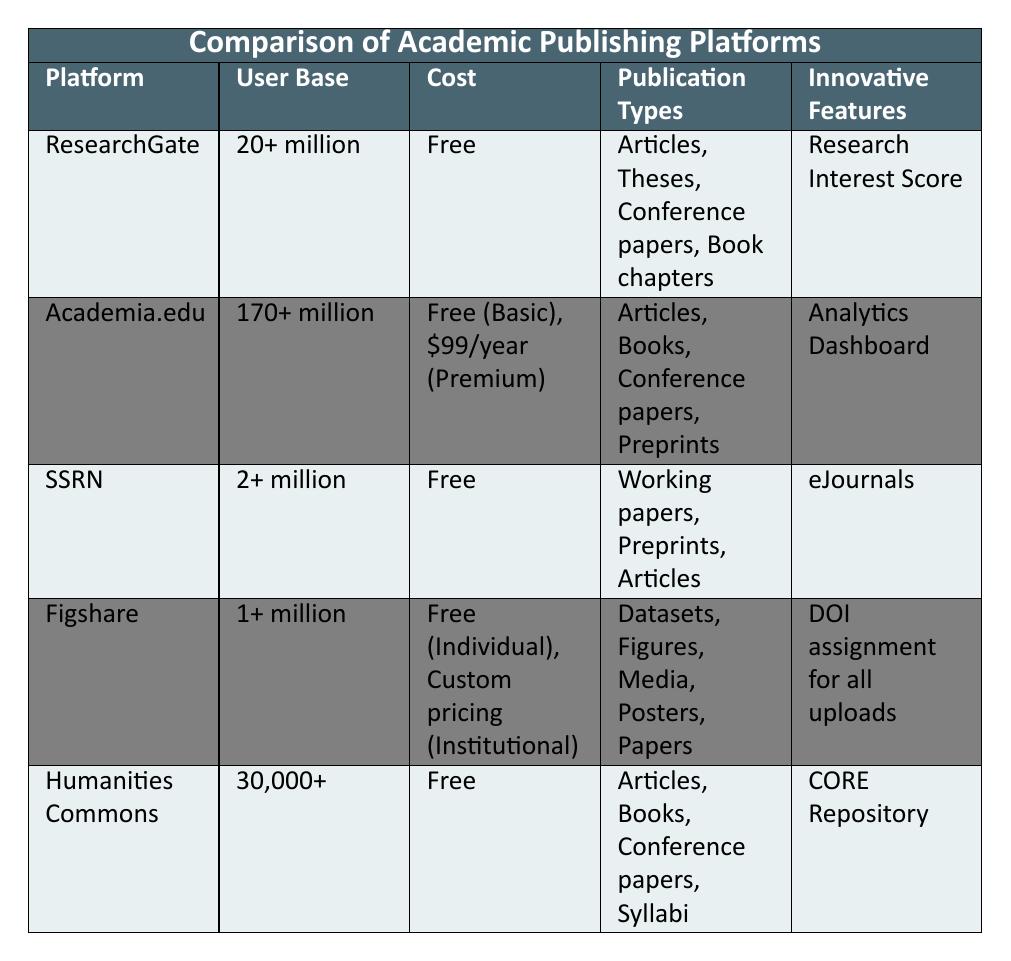What is the user base of Academia.edu? The user base for Academia.edu is explicitly stated in the table as "170+ million."
Answer: 170+ million Which platform has the largest user base? By comparing the user bases of all the platforms listed, Academia.edu has "170+ million," which is greater than the others: ResearchGate (20+ million), SSRN (2+ million), Figshare (1+ million), and Humanities Commons (30,000+).
Answer: Academia.edu Does SSRN offer free access? The table specifies that SSRN is "Free." Therefore, the answer is yes.
Answer: Yes Which platforms support open access? The open access support column shows "Yes" for ResearchGate, Academia.edu, SSRN, Figshare, and Humanities Commons. Therefore, all listed platforms support open access.
Answer: Yes What types of publications does Figshare allow? The publication types for Figshare listed in the table are "Datasets, Figures, Media, Posters, Papers."
Answer: Datasets, Figures, Media, Posters, Papers How many million users does ResearchGate have compared to Humanities Commons? ResearchGate has "20+ million" users while Humanities Commons has "30,000+." The difference shows that ResearchGate has significantly more users when converted, which is a difference of 20 million (20,000,000 - 30,000).
Answer: ResearchGate has 20 million more users Which platform has an Analytics Dashboard as an innovative feature? Referring to the innovative features, the table lists "Analytics Dashboard" under Academia.edu.
Answer: Academia.edu Do both Figshare and SSRN allow for articles as a publication type? The publication types show that SSRN allows "Working papers, Preprints, Articles," and Figshare allows "Datasets, Figures, Media, Posters, Papers." Since SSRN explicitly includes "Articles," and Figshare does not, the answer is no.
Answer: No Which platforms provide integration with Mendeley? The integration with reference managers shows that ResearchGate and Figshare integrate with Mendeley, while other platforms either use Zotero or EndNote.
Answer: ResearchGate and Figshare What is the total unique publication types offered by all the platforms combined? By summing the unique publication types across all platforms, we have ResearchGate (4 types), Academia.edu (4 types), SSRN (3 types), Figshare (5 types), and Humanities Commons (4 types), leading to a total of 20 unique types. However, accounting for overlaps, it might be fewer, but the data does not specify, so we will use the sum which is 20.
Answer: 20 